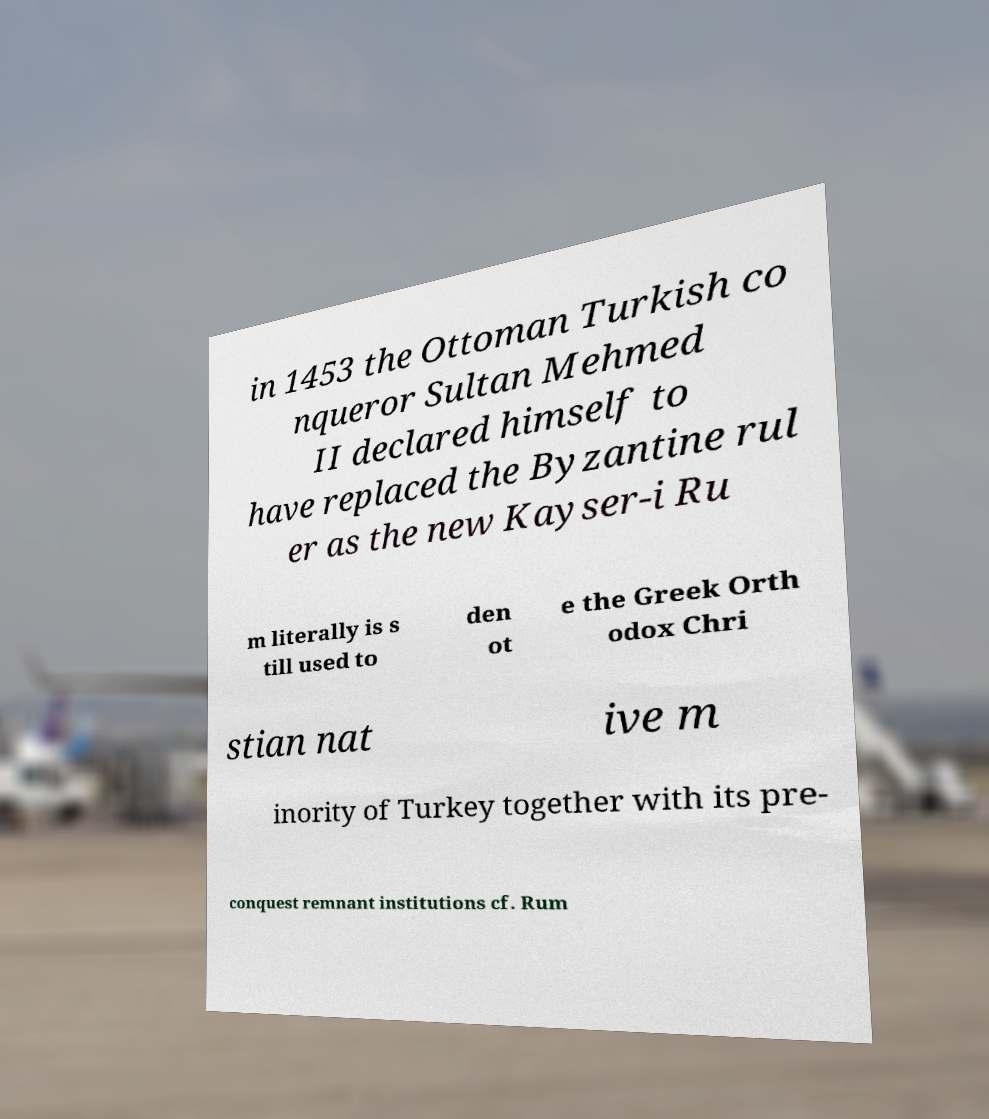For documentation purposes, I need the text within this image transcribed. Could you provide that? in 1453 the Ottoman Turkish co nqueror Sultan Mehmed II declared himself to have replaced the Byzantine rul er as the new Kayser-i Ru m literally is s till used to den ot e the Greek Orth odox Chri stian nat ive m inority of Turkey together with its pre- conquest remnant institutions cf. Rum 